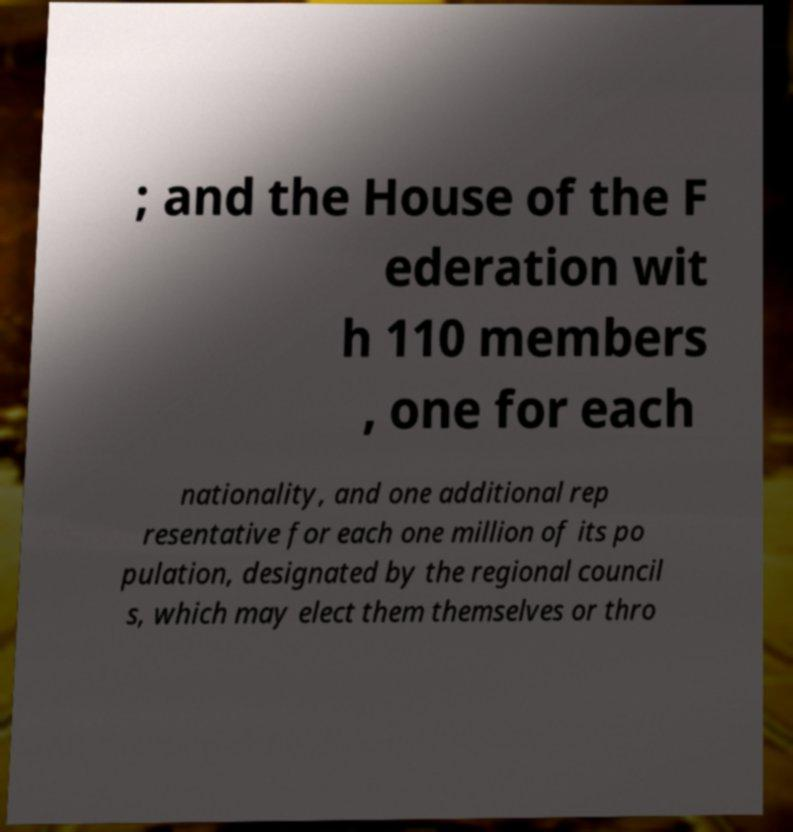For documentation purposes, I need the text within this image transcribed. Could you provide that? ; and the House of the F ederation wit h 110 members , one for each nationality, and one additional rep resentative for each one million of its po pulation, designated by the regional council s, which may elect them themselves or thro 